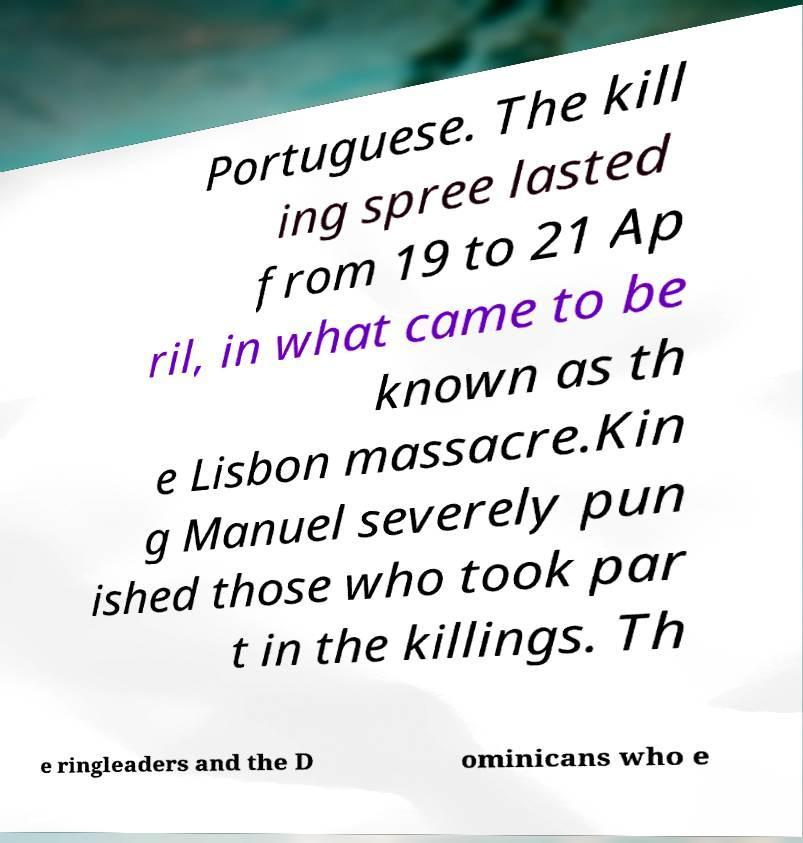Could you assist in decoding the text presented in this image and type it out clearly? Portuguese. The kill ing spree lasted from 19 to 21 Ap ril, in what came to be known as th e Lisbon massacre.Kin g Manuel severely pun ished those who took par t in the killings. Th e ringleaders and the D ominicans who e 